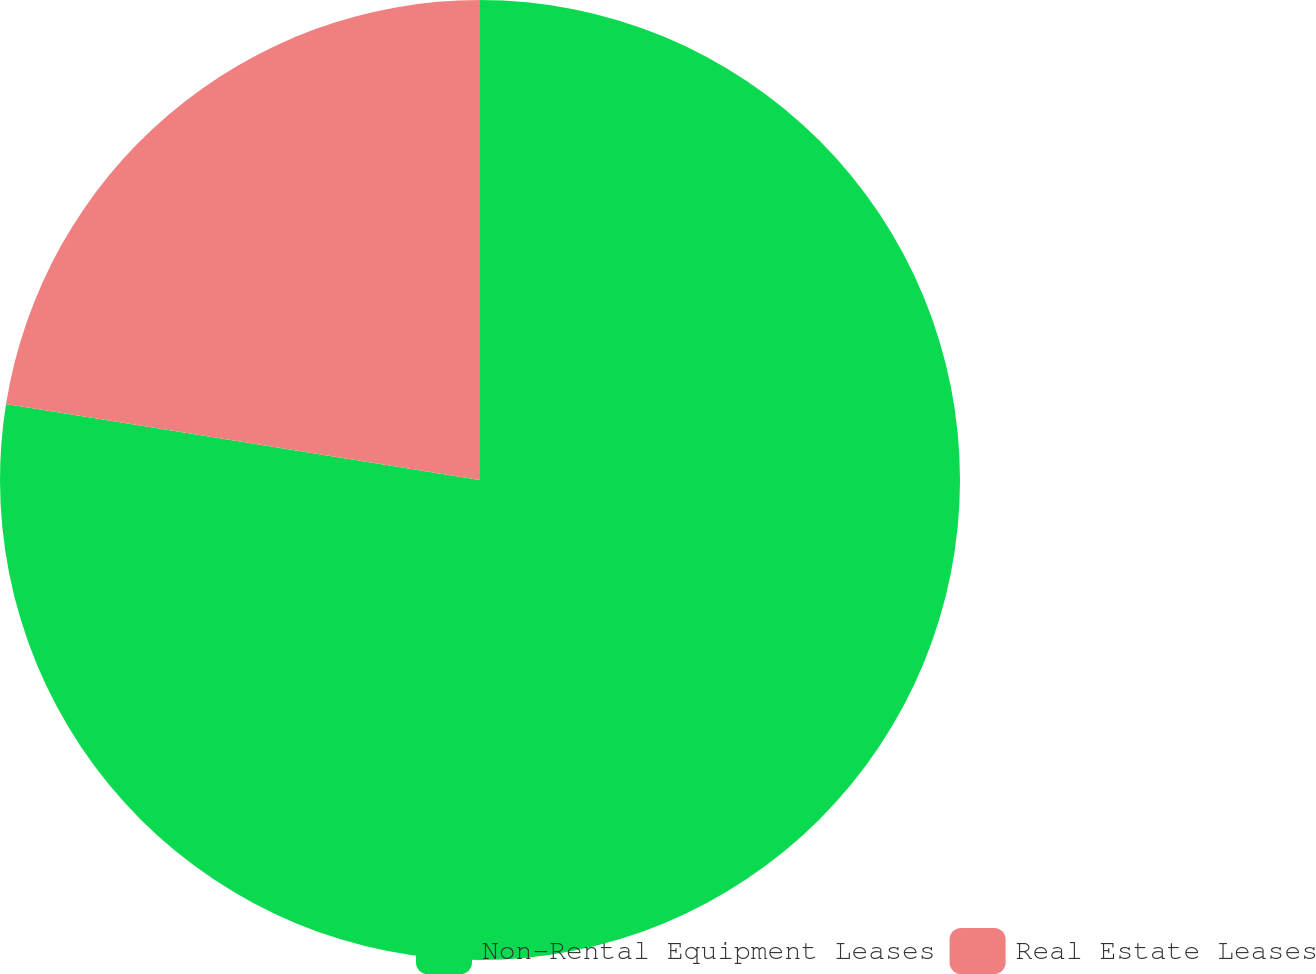<chart> <loc_0><loc_0><loc_500><loc_500><pie_chart><fcel>Non-Rental Equipment Leases<fcel>Real Estate Leases<nl><fcel>77.53%<fcel>22.47%<nl></chart> 